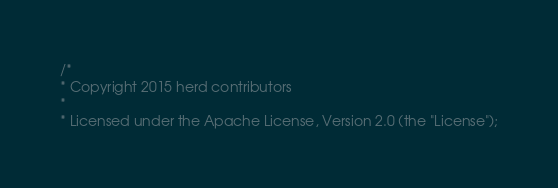<code> <loc_0><loc_0><loc_500><loc_500><_SQL_>/*
* Copyright 2015 herd contributors
*
* Licensed under the Apache License, Version 2.0 (the "License");</code> 